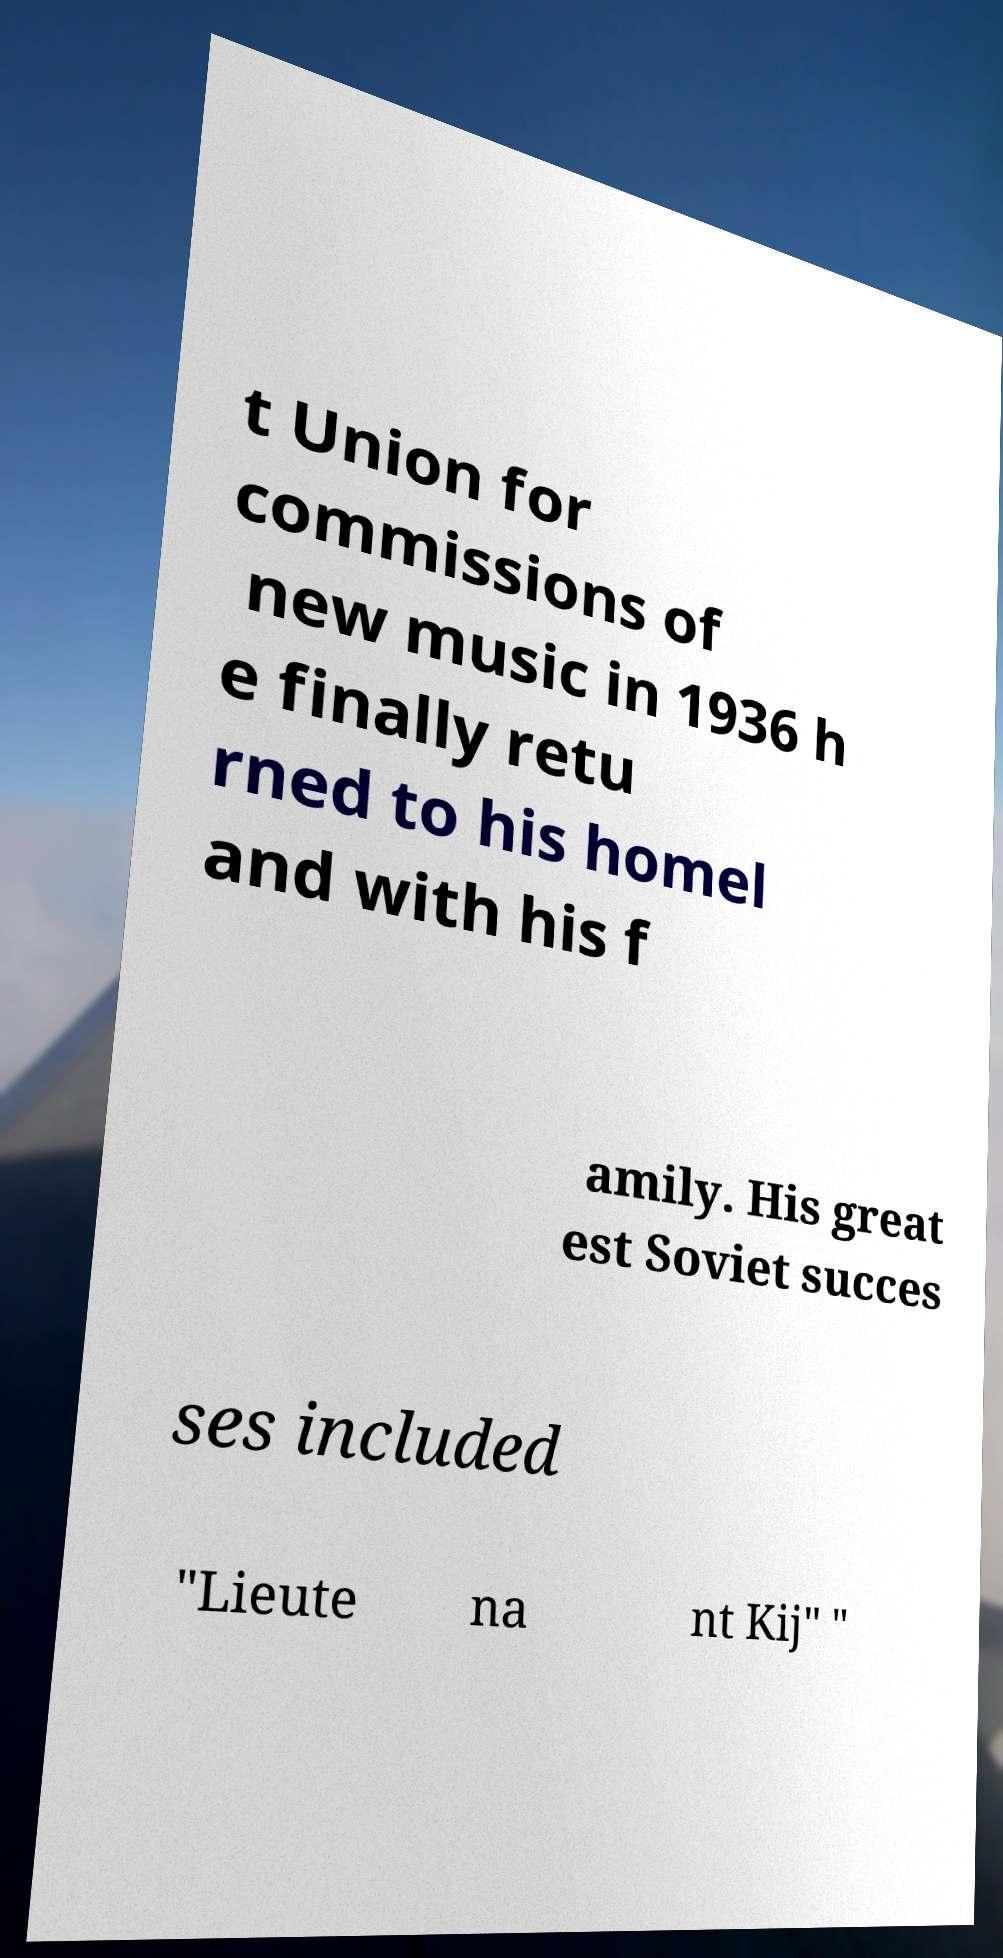Can you accurately transcribe the text from the provided image for me? t Union for commissions of new music in 1936 h e finally retu rned to his homel and with his f amily. His great est Soviet succes ses included "Lieute na nt Kij" " 